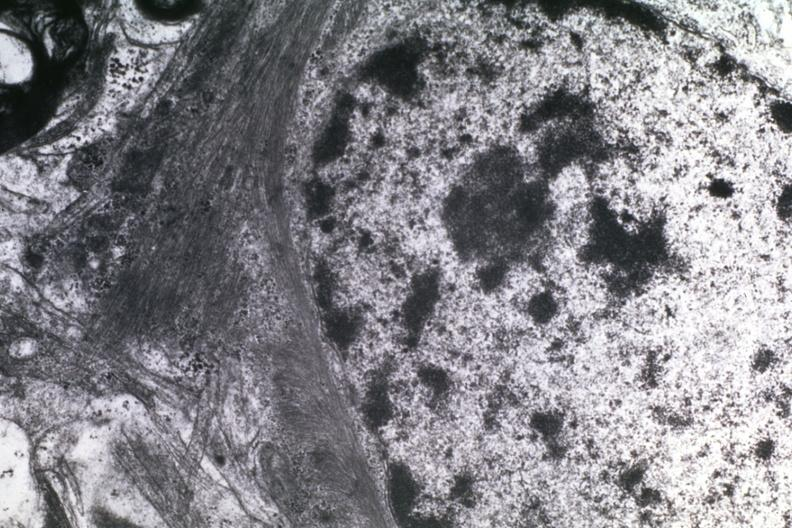what does this image show?
Answer the question using a single word or phrase. Dr garcia tumors 15 